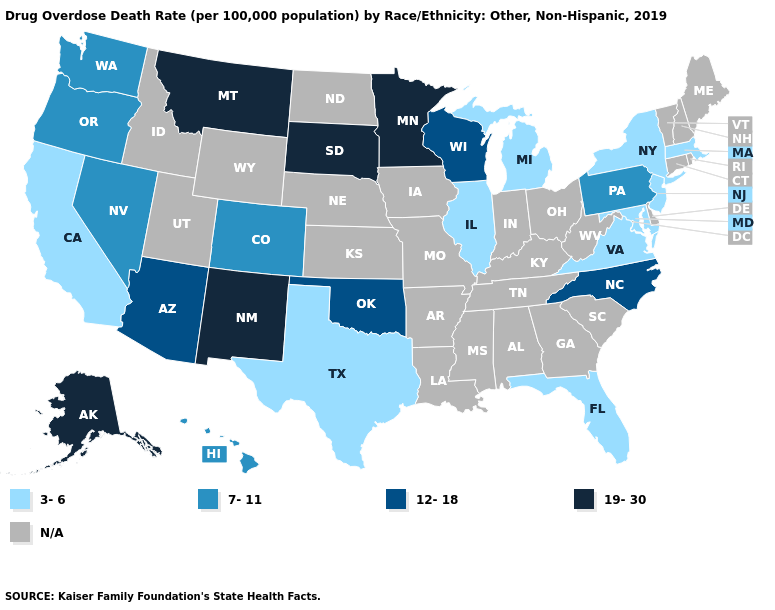What is the value of Delaware?
Write a very short answer. N/A. Does the first symbol in the legend represent the smallest category?
Give a very brief answer. Yes. What is the value of Mississippi?
Give a very brief answer. N/A. How many symbols are there in the legend?
Be succinct. 5. Among the states that border Connecticut , which have the lowest value?
Be succinct. Massachusetts, New York. Name the states that have a value in the range N/A?
Quick response, please. Alabama, Arkansas, Connecticut, Delaware, Georgia, Idaho, Indiana, Iowa, Kansas, Kentucky, Louisiana, Maine, Mississippi, Missouri, Nebraska, New Hampshire, North Dakota, Ohio, Rhode Island, South Carolina, Tennessee, Utah, Vermont, West Virginia, Wyoming. What is the highest value in the USA?
Be succinct. 19-30. Name the states that have a value in the range 3-6?
Answer briefly. California, Florida, Illinois, Maryland, Massachusetts, Michigan, New Jersey, New York, Texas, Virginia. Name the states that have a value in the range 3-6?
Short answer required. California, Florida, Illinois, Maryland, Massachusetts, Michigan, New Jersey, New York, Texas, Virginia. Which states hav the highest value in the South?
Give a very brief answer. North Carolina, Oklahoma. How many symbols are there in the legend?
Give a very brief answer. 5. What is the value of Rhode Island?
Concise answer only. N/A. 